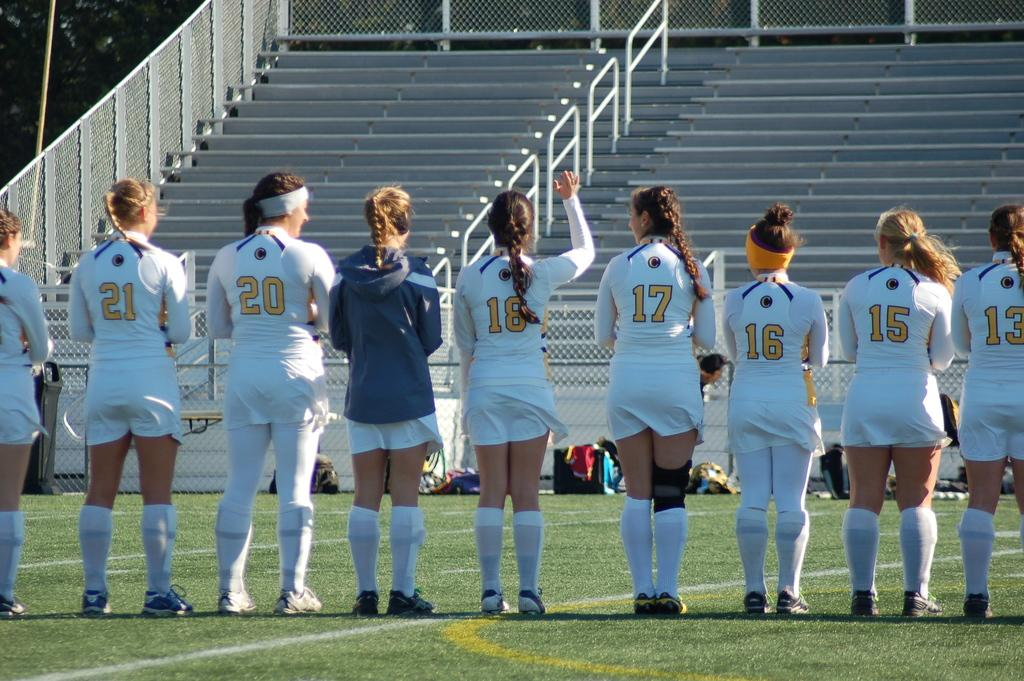Provide a one-sentence caption for the provided image. Soccer players line up on the field with number 13 to the far right. 